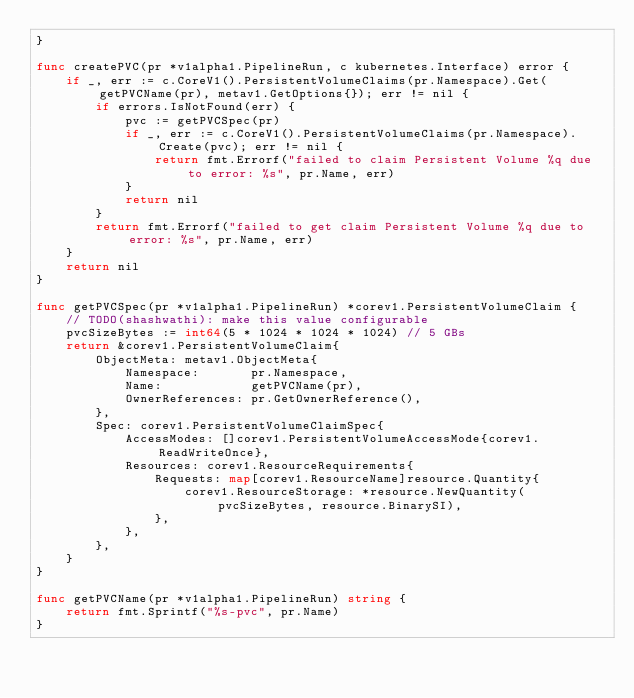Convert code to text. <code><loc_0><loc_0><loc_500><loc_500><_Go_>}

func createPVC(pr *v1alpha1.PipelineRun, c kubernetes.Interface) error {
	if _, err := c.CoreV1().PersistentVolumeClaims(pr.Namespace).Get(getPVCName(pr), metav1.GetOptions{}); err != nil {
		if errors.IsNotFound(err) {
			pvc := getPVCSpec(pr)
			if _, err := c.CoreV1().PersistentVolumeClaims(pr.Namespace).Create(pvc); err != nil {
				return fmt.Errorf("failed to claim Persistent Volume %q due to error: %s", pr.Name, err)
			}
			return nil
		}
		return fmt.Errorf("failed to get claim Persistent Volume %q due to error: %s", pr.Name, err)
	}
	return nil
}

func getPVCSpec(pr *v1alpha1.PipelineRun) *corev1.PersistentVolumeClaim {
	// TODO(shashwathi): make this value configurable
	pvcSizeBytes := int64(5 * 1024 * 1024 * 1024) // 5 GBs
	return &corev1.PersistentVolumeClaim{
		ObjectMeta: metav1.ObjectMeta{
			Namespace:       pr.Namespace,
			Name:            getPVCName(pr),
			OwnerReferences: pr.GetOwnerReference(),
		},
		Spec: corev1.PersistentVolumeClaimSpec{
			AccessModes: []corev1.PersistentVolumeAccessMode{corev1.ReadWriteOnce},
			Resources: corev1.ResourceRequirements{
				Requests: map[corev1.ResourceName]resource.Quantity{
					corev1.ResourceStorage: *resource.NewQuantity(pvcSizeBytes, resource.BinarySI),
				},
			},
		},
	}
}

func getPVCName(pr *v1alpha1.PipelineRun) string {
	return fmt.Sprintf("%s-pvc", pr.Name)
}
</code> 